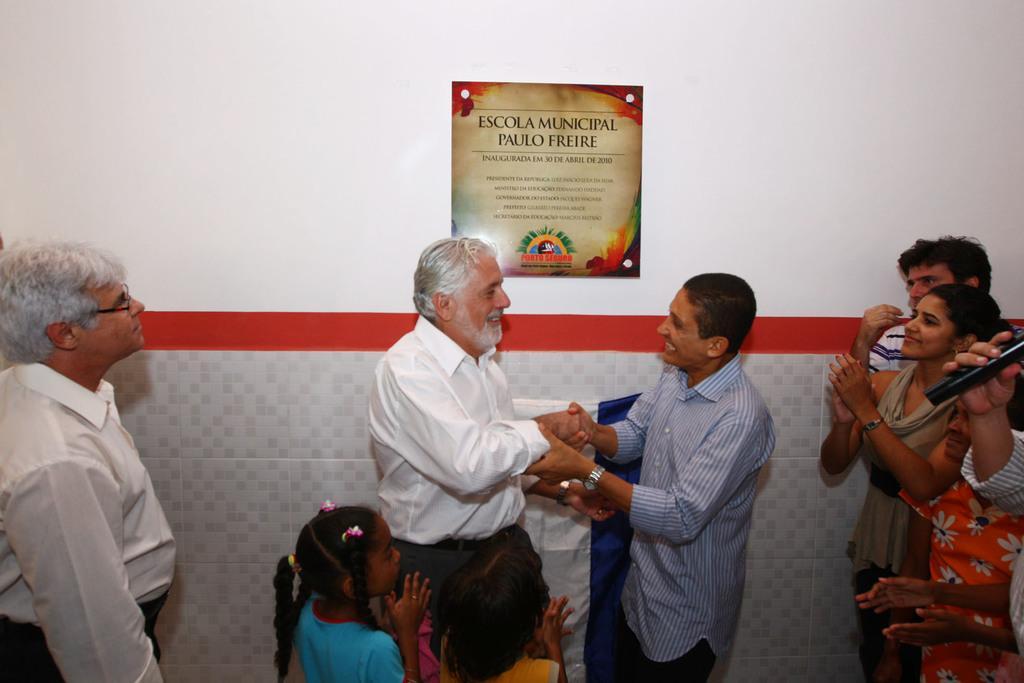Describe this image in one or two sentences. On the left side, there is a person in a white color shirt, wearing a spectacle and standing. On the right side, there are four persons. One of them is holding a microphone. In front of them, there are two persons in different color dresses, shaking hands. Beside them, there are two children. In the background, there is a poster attached to the white wall. 